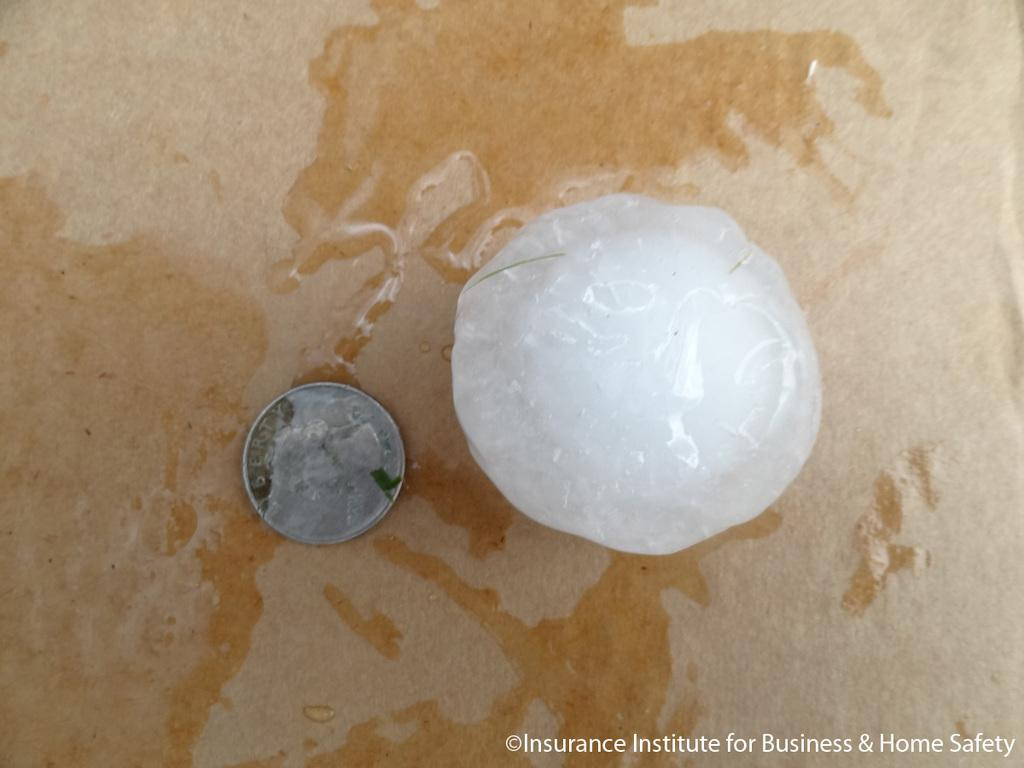Provide a one-sentence caption for the provided image. Liberty silver coin beside a clear ball that is wet. 